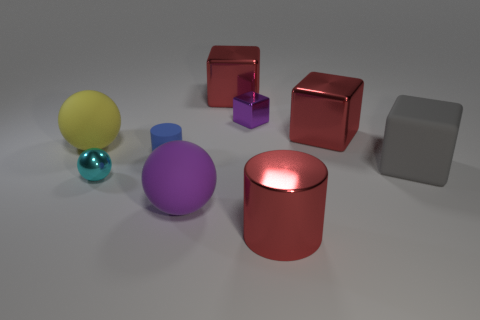Add 1 tiny red spheres. How many objects exist? 10 Subtract all balls. How many objects are left? 6 Add 3 purple rubber objects. How many purple rubber objects exist? 4 Subtract 1 purple balls. How many objects are left? 8 Subtract all brown balls. Subtract all big blocks. How many objects are left? 6 Add 7 cyan metallic things. How many cyan metallic things are left? 8 